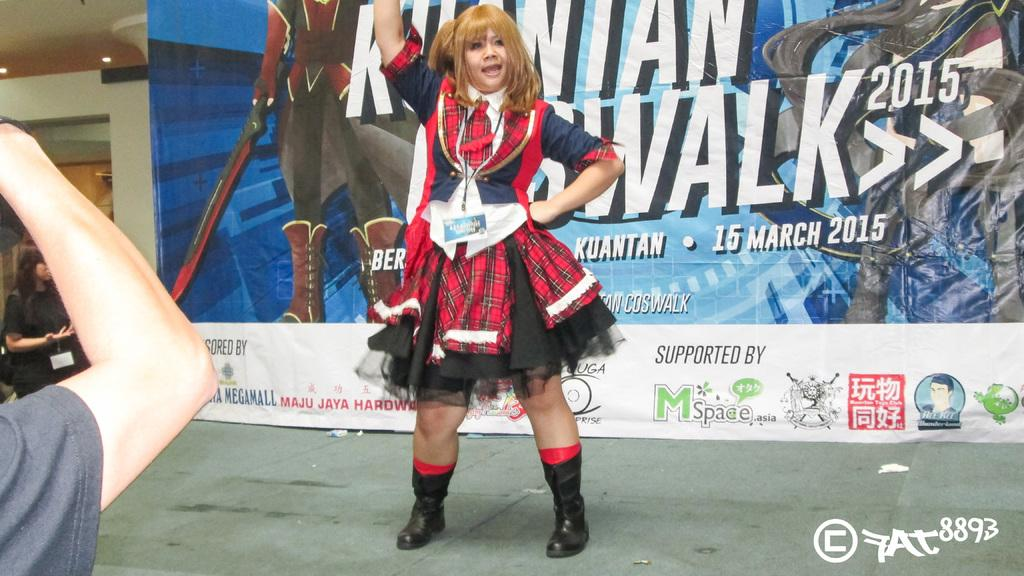<image>
Create a compact narrative representing the image presented. a woman posing in front a billboard that say walk 